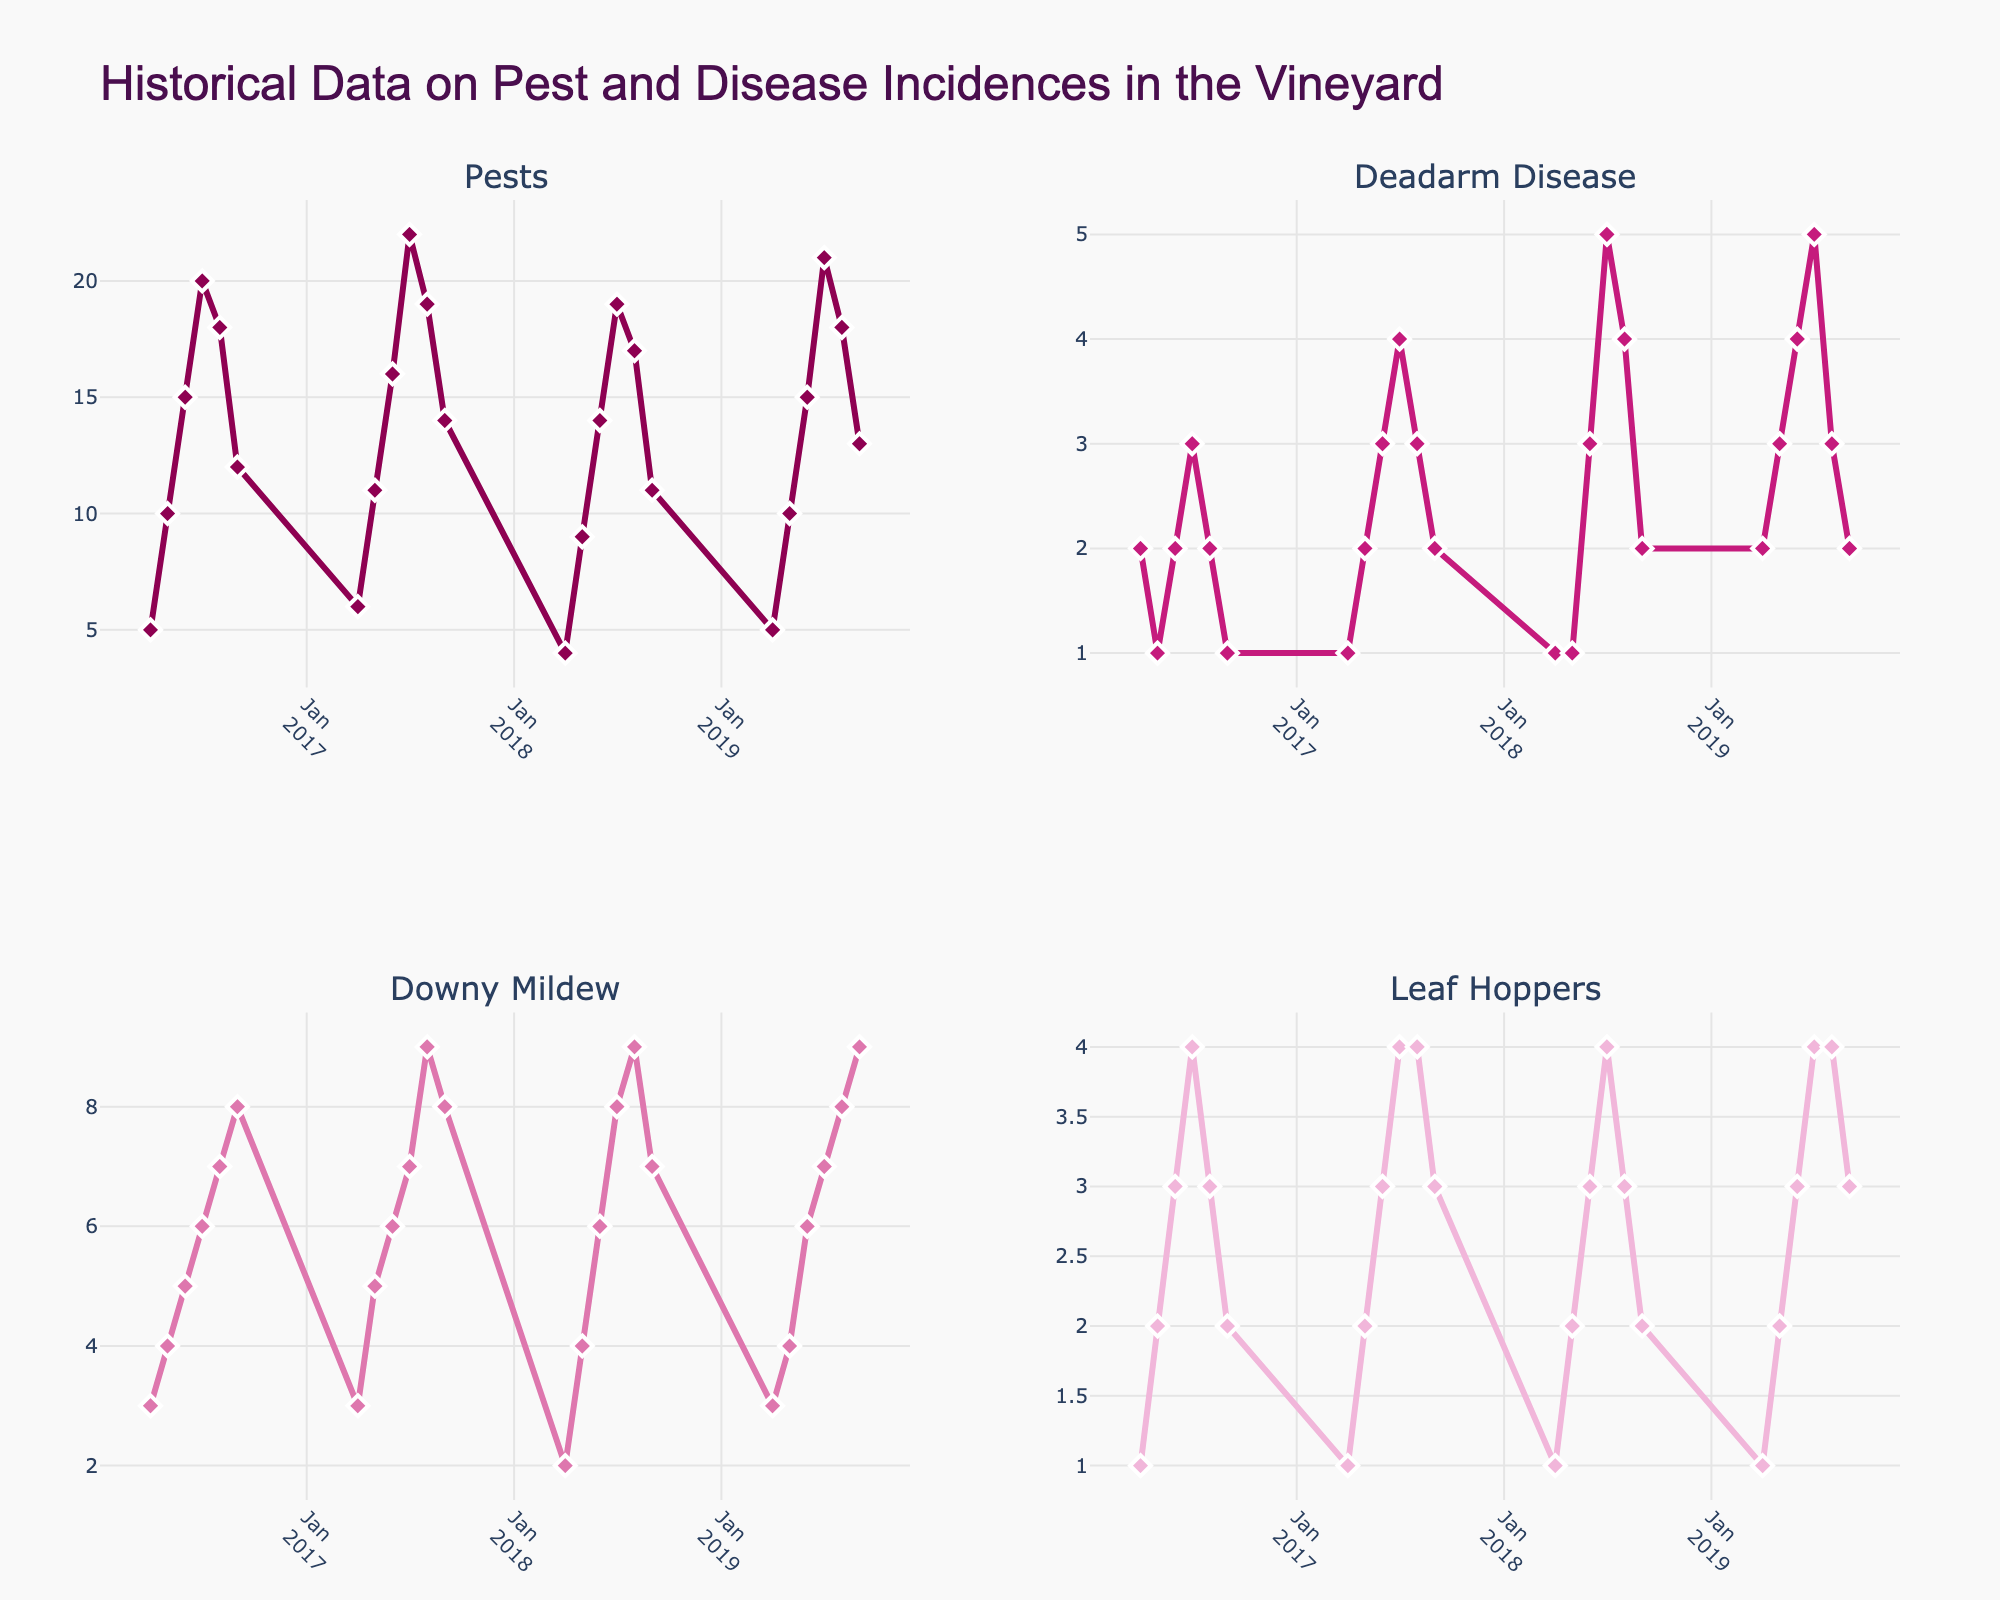What is the title of the plot? The title is generally positioned at the top of the figure and usually summarizes the content of the plot. In this case, the title is given as "Historical Data on Pest and Disease Incidences in the Vineyard".
Answer: Historical Data on Pest and Disease Incidences in the Vineyard How many pests incidents were recorded in July 2019? First, locate July 2019 on the Date axis in the subplot labeled 'Pests'. Then, read the corresponding value on the vertical axis. The pests incident count here is 21.
Answer: 21 Which disease or pest had the highest incidence in August 2017? Look at the data points for each subplot in August 2017. Compare the values and identify the highest one. For August 2017: Pests had 19, Deadarm Disease had 3, Downy Mildew had 9, Leaf Hoppers had 4. The highest value is in the Downy Mildew subplot.
Answer: Downy Mildew What is the average number of pests recorded in the month of May across all the years? To find the average: add the values for May from each year (10 in 2016, 11 in 2017, 9 in 2018, and 10 in 2019). Then, divide by the number of values. That’s (10 + 11 + 9 + 10) / 4 = 40 / 4 = 10.
Answer: 10 Between September 2016 and September 2019, in which month-year did Deadarm Disease reach its peak value? Look at the highest value in the Deadarm Disease subplot between the given dates. Deadarm Disease peaked in July 2019 with a value of 5.
Answer: July 2019 How did the incidence of Leaf Hoppers change from September 2016 to September 2019? Locate the points for Leaf Hoppers in September 2016 and September 2019. Compare the values: 2 in September 2016 and 3 in September 2019. The incidence increased slightly.
Answer: Increased What is the combined total of Downy Mildew incidences recorded in June for all the years? Add the incidences of Downy Mildew for June across all the years: (5 in 2016, 6 in 2017, 6 in 2018, and 6 in 2019). This gives 5 + 6 + 6 + 6 = 23.
Answer: 23 Which month-year shows the lowest recorded value for pests? Check the Pests subplot for the lowest number. The lowest recorded value is 4 in April 2018.
Answer: April 2018 Compare the general trend of Downy Mildew to Deadarm Disease over the years. How do they differ? Observe how Downy Mildew and Deadarm Disease behave over the timeline. Downy Mildew generally increases during the summer months (June to September) and peaks in August, whereas Deadarm Disease shows less variation and peaks in July.
Answer: Downy Mildew increases more significantly in summer than Deadarm Disease What is the difference in the total number of pests recorded between July 2016 and July 2017? Find the value for Pests in July 2016 (20) and July 2017 (22). Calculate the difference: 22 - 20. The difference is 2.
Answer: 2 